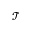<formula> <loc_0><loc_0><loc_500><loc_500>\mathcal { T }</formula> 